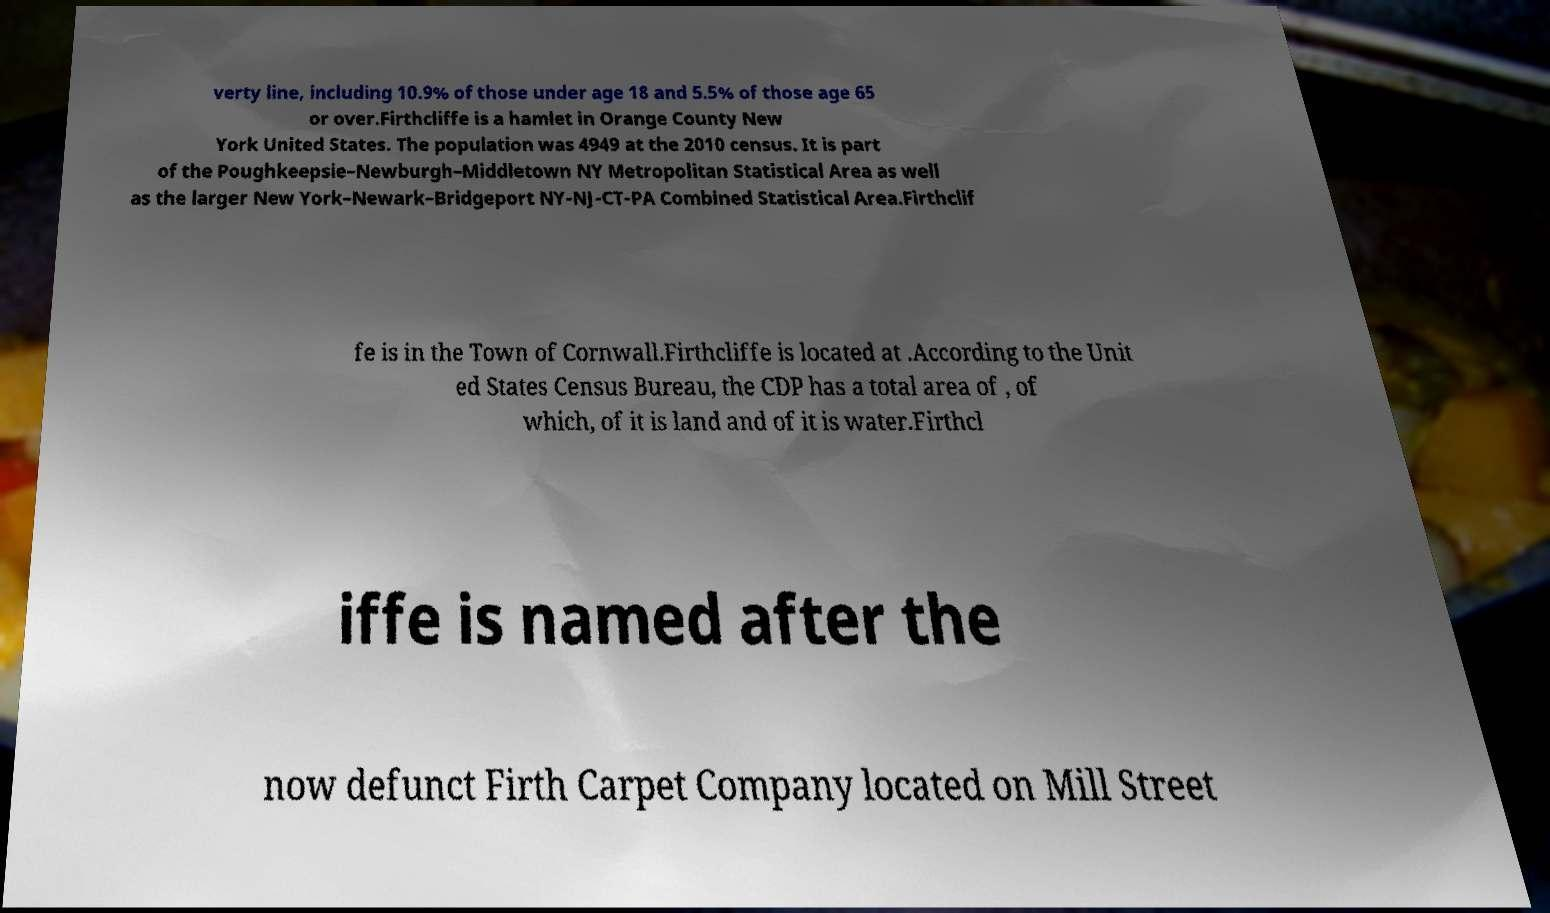Could you extract and type out the text from this image? verty line, including 10.9% of those under age 18 and 5.5% of those age 65 or over.Firthcliffe is a hamlet in Orange County New York United States. The population was 4949 at the 2010 census. It is part of the Poughkeepsie–Newburgh–Middletown NY Metropolitan Statistical Area as well as the larger New York–Newark–Bridgeport NY-NJ-CT-PA Combined Statistical Area.Firthclif fe is in the Town of Cornwall.Firthcliffe is located at .According to the Unit ed States Census Bureau, the CDP has a total area of , of which, of it is land and of it is water.Firthcl iffe is named after the now defunct Firth Carpet Company located on Mill Street 